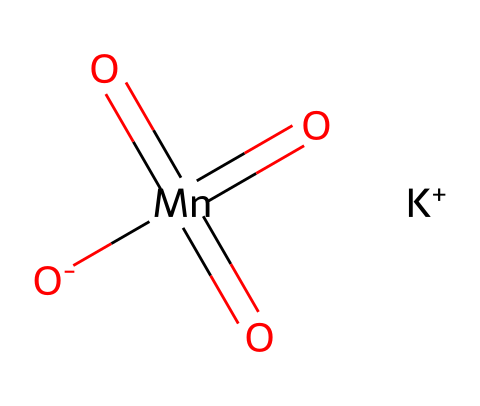What is the main cation present in potassium permanganate? The chemical contains a potassium atom denoted as K+, which indicates the presence of the cation.
Answer: potassium How many oxygen atoms are present in potassium permanganate? The SMILES representation shows four oxygen atoms connected to the manganese atom, which verifies the number of oxygen atoms present.
Answer: four What is the oxidation state of manganese in potassium permanganate? Observing the structure, manganese is in a +7 oxidation state based on its bonding with four oxygens, concluding its elevated oxidation level.
Answer: +7 What type of chemical is potassium permanganate classified as? The chemical structure indicates it has strong oxidizing properties; thus, it falls under the category of oxidizers used in reactions like water purification.
Answer: oxidizer How many double bonds are present in the molecular structure of potassium permanganate? The structure illustrates two double bonds between manganese and two of the four oxygen atoms, confirming the count of double bonds in the molecule.
Answer: two 